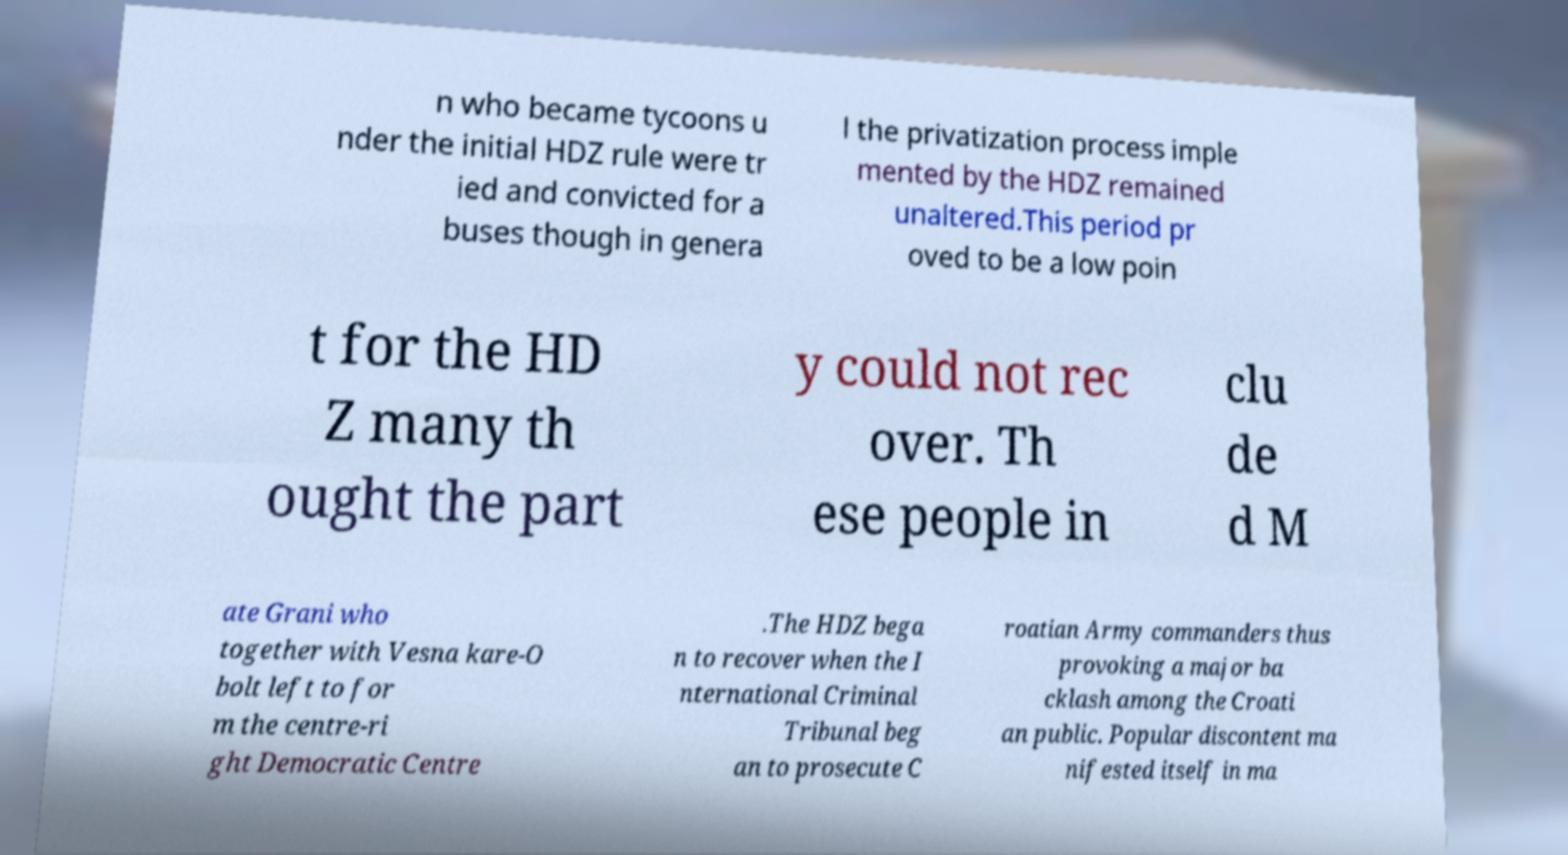Please read and relay the text visible in this image. What does it say? n who became tycoons u nder the initial HDZ rule were tr ied and convicted for a buses though in genera l the privatization process imple mented by the HDZ remained unaltered.This period pr oved to be a low poin t for the HD Z many th ought the part y could not rec over. Th ese people in clu de d M ate Grani who together with Vesna kare-O bolt left to for m the centre-ri ght Democratic Centre .The HDZ bega n to recover when the I nternational Criminal Tribunal beg an to prosecute C roatian Army commanders thus provoking a major ba cklash among the Croati an public. Popular discontent ma nifested itself in ma 